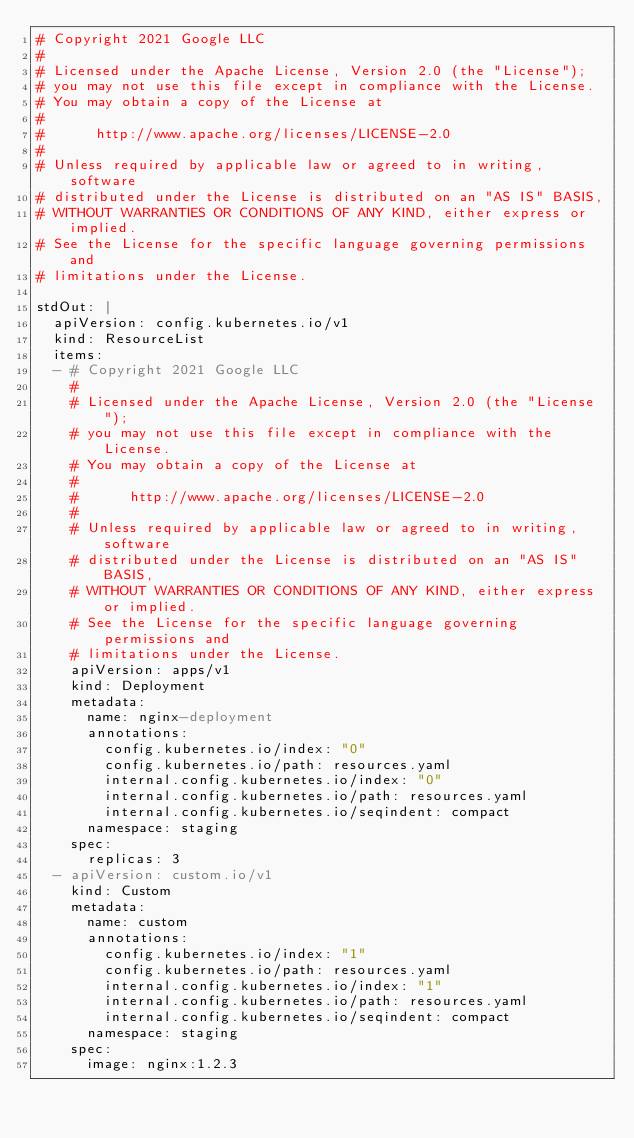Convert code to text. <code><loc_0><loc_0><loc_500><loc_500><_YAML_># Copyright 2021 Google LLC
#
# Licensed under the Apache License, Version 2.0 (the "License");
# you may not use this file except in compliance with the License.
# You may obtain a copy of the License at
#
#      http://www.apache.org/licenses/LICENSE-2.0
#
# Unless required by applicable law or agreed to in writing, software
# distributed under the License is distributed on an "AS IS" BASIS,
# WITHOUT WARRANTIES OR CONDITIONS OF ANY KIND, either express or implied.
# See the License for the specific language governing permissions and
# limitations under the License.

stdOut: |
  apiVersion: config.kubernetes.io/v1
  kind: ResourceList
  items:
  - # Copyright 2021 Google LLC
    #
    # Licensed under the Apache License, Version 2.0 (the "License");
    # you may not use this file except in compliance with the License.
    # You may obtain a copy of the License at
    #
    #      http://www.apache.org/licenses/LICENSE-2.0
    #
    # Unless required by applicable law or agreed to in writing, software
    # distributed under the License is distributed on an "AS IS" BASIS,
    # WITHOUT WARRANTIES OR CONDITIONS OF ANY KIND, either express or implied.
    # See the License for the specific language governing permissions and
    # limitations under the License.
    apiVersion: apps/v1
    kind: Deployment
    metadata:
      name: nginx-deployment
      annotations:
        config.kubernetes.io/index: "0"
        config.kubernetes.io/path: resources.yaml
        internal.config.kubernetes.io/index: "0"
        internal.config.kubernetes.io/path: resources.yaml
        internal.config.kubernetes.io/seqindent: compact
      namespace: staging
    spec:
      replicas: 3
  - apiVersion: custom.io/v1
    kind: Custom
    metadata:
      name: custom
      annotations:
        config.kubernetes.io/index: "1"
        config.kubernetes.io/path: resources.yaml
        internal.config.kubernetes.io/index: "1"
        internal.config.kubernetes.io/path: resources.yaml
        internal.config.kubernetes.io/seqindent: compact
      namespace: staging
    spec:
      image: nginx:1.2.3
</code> 